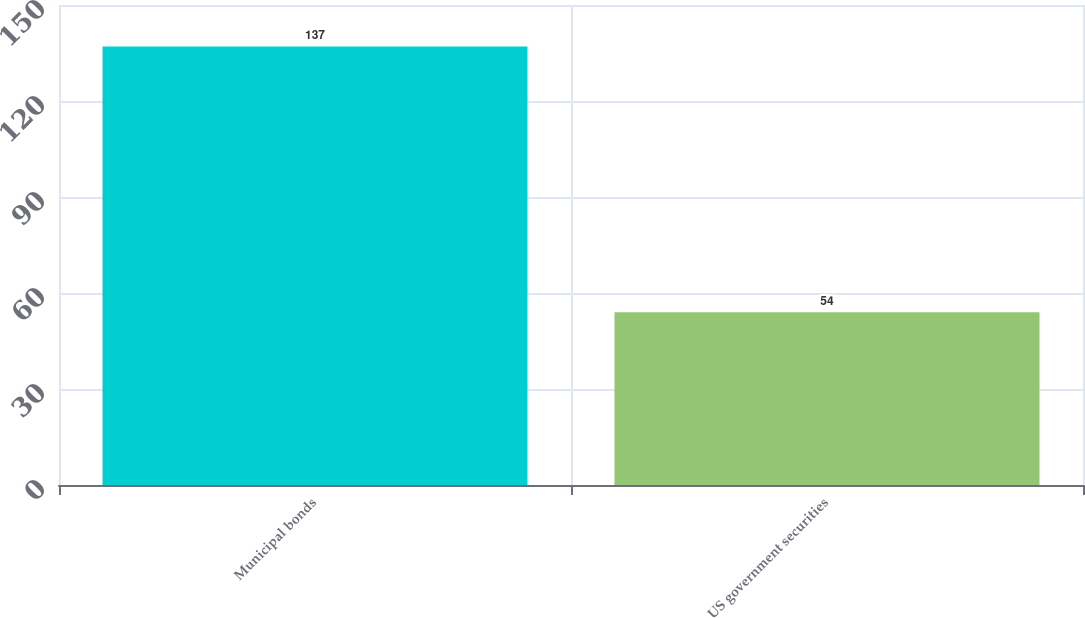<chart> <loc_0><loc_0><loc_500><loc_500><bar_chart><fcel>Municipal bonds<fcel>US government securities<nl><fcel>137<fcel>54<nl></chart> 